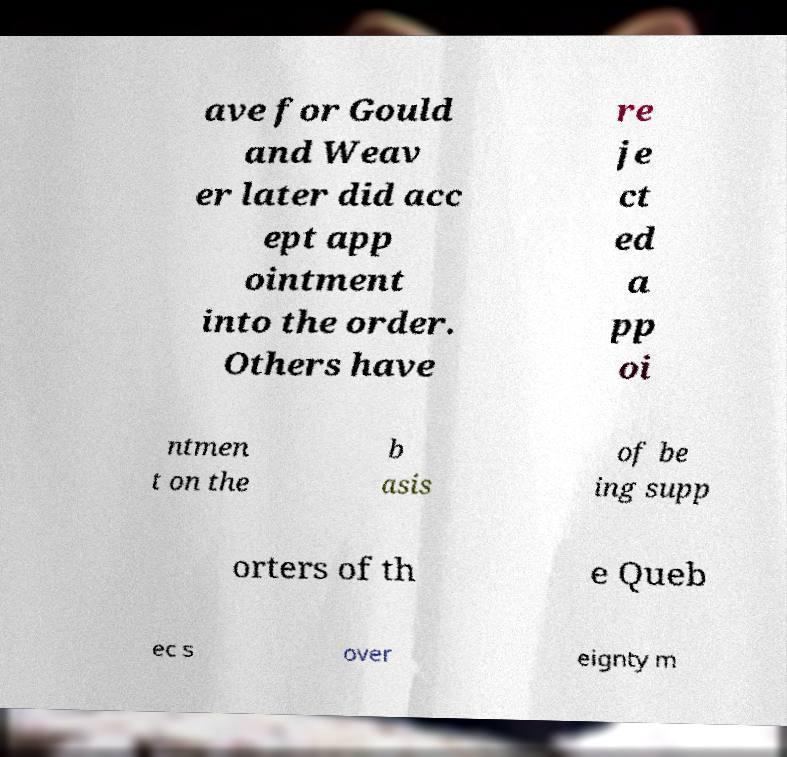Could you extract and type out the text from this image? ave for Gould and Weav er later did acc ept app ointment into the order. Others have re je ct ed a pp oi ntmen t on the b asis of be ing supp orters of th e Queb ec s over eignty m 